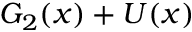<formula> <loc_0><loc_0><loc_500><loc_500>G _ { 2 } ( x ) + U ( x )</formula> 